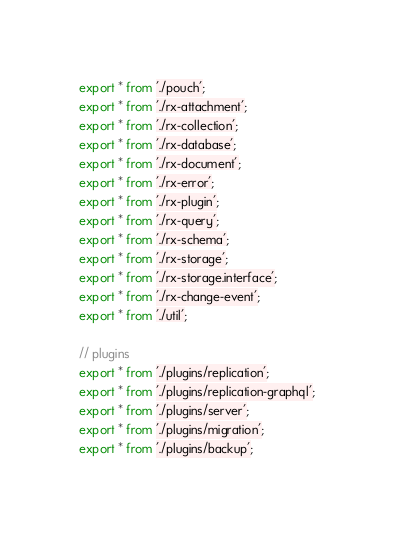<code> <loc_0><loc_0><loc_500><loc_500><_TypeScript_>export * from './pouch';
export * from './rx-attachment';
export * from './rx-collection';
export * from './rx-database';
export * from './rx-document';
export * from './rx-error';
export * from './rx-plugin';
export * from './rx-query';
export * from './rx-schema';
export * from './rx-storage';
export * from './rx-storage.interface';
export * from './rx-change-event';
export * from './util';

// plugins
export * from './plugins/replication';
export * from './plugins/replication-graphql';
export * from './plugins/server';
export * from './plugins/migration';
export * from './plugins/backup';
</code> 